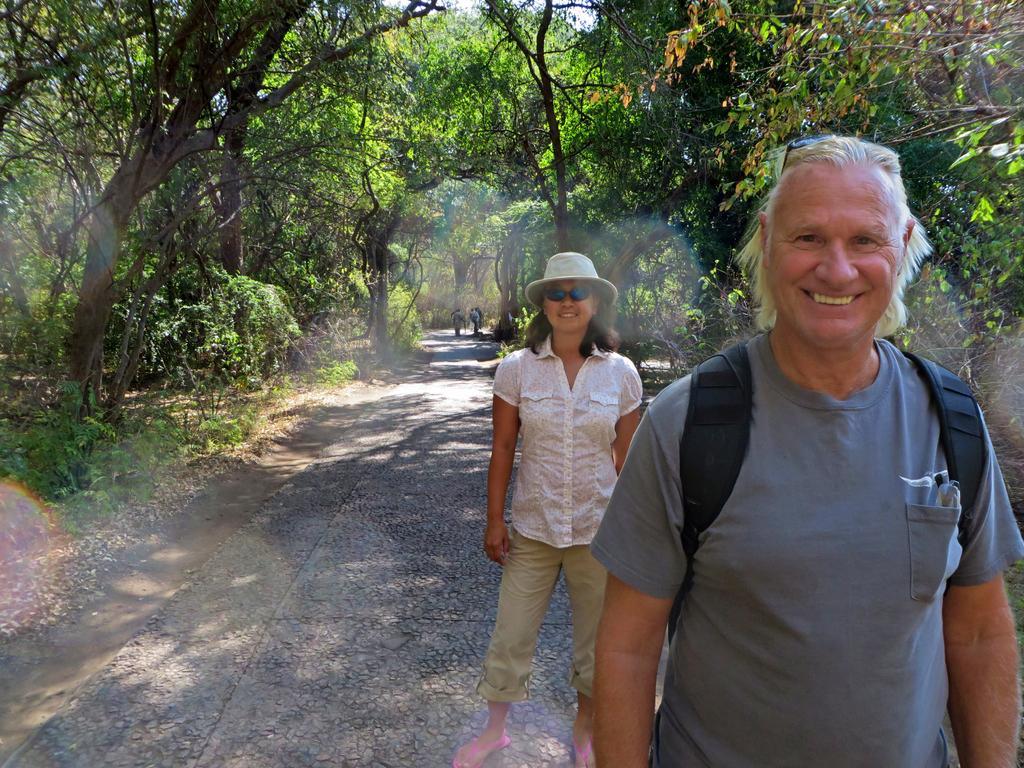In one or two sentences, can you explain what this image depicts? In this picture we can see a man and a woman on the path. There are a few people visible at the back. We can see a few plants and trees in the background. 